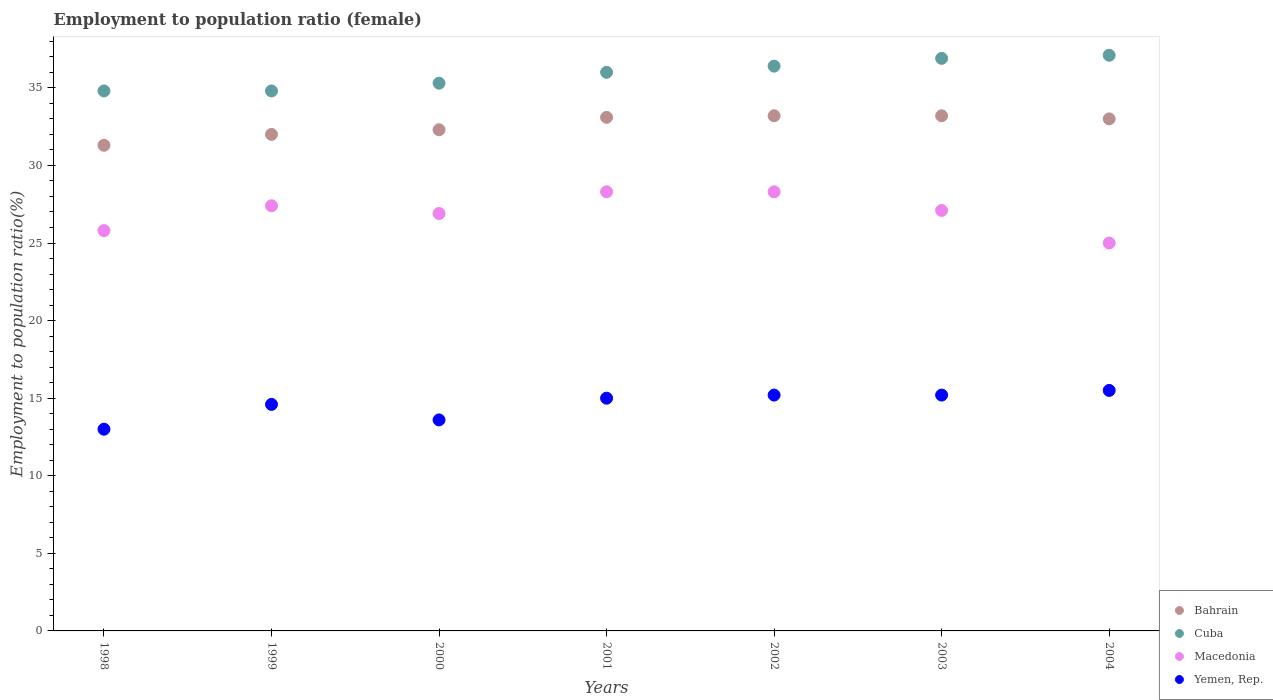What is the employment to population ratio in Yemen, Rep. in 1998?
Keep it short and to the point. 13. Across all years, what is the maximum employment to population ratio in Macedonia?
Your answer should be very brief. 28.3. Across all years, what is the minimum employment to population ratio in Yemen, Rep.?
Give a very brief answer. 13. In which year was the employment to population ratio in Macedonia minimum?
Give a very brief answer. 2004. What is the total employment to population ratio in Yemen, Rep. in the graph?
Give a very brief answer. 102.1. What is the difference between the employment to population ratio in Macedonia in 2000 and that in 2003?
Your answer should be compact. -0.2. What is the difference between the employment to population ratio in Macedonia in 2002 and the employment to population ratio in Bahrain in 1999?
Your answer should be very brief. -3.7. What is the average employment to population ratio in Macedonia per year?
Your answer should be compact. 26.97. In the year 2003, what is the difference between the employment to population ratio in Bahrain and employment to population ratio in Cuba?
Give a very brief answer. -3.7. What is the ratio of the employment to population ratio in Bahrain in 2002 to that in 2004?
Offer a terse response. 1.01. Is the employment to population ratio in Yemen, Rep. in 1999 less than that in 2001?
Give a very brief answer. Yes. Is the difference between the employment to population ratio in Bahrain in 2001 and 2002 greater than the difference between the employment to population ratio in Cuba in 2001 and 2002?
Provide a short and direct response. Yes. What is the difference between the highest and the second highest employment to population ratio in Cuba?
Make the answer very short. 0.2. What is the difference between the highest and the lowest employment to population ratio in Yemen, Rep.?
Your answer should be compact. 2.5. Is the sum of the employment to population ratio in Cuba in 2000 and 2001 greater than the maximum employment to population ratio in Bahrain across all years?
Make the answer very short. Yes. Is it the case that in every year, the sum of the employment to population ratio in Cuba and employment to population ratio in Bahrain  is greater than the sum of employment to population ratio in Macedonia and employment to population ratio in Yemen, Rep.?
Your response must be concise. No. Is it the case that in every year, the sum of the employment to population ratio in Macedonia and employment to population ratio in Bahrain  is greater than the employment to population ratio in Cuba?
Your response must be concise. Yes. Is the employment to population ratio in Cuba strictly less than the employment to population ratio in Yemen, Rep. over the years?
Your answer should be very brief. No. How many dotlines are there?
Give a very brief answer. 4. What is the difference between two consecutive major ticks on the Y-axis?
Give a very brief answer. 5. Does the graph contain grids?
Make the answer very short. No. Where does the legend appear in the graph?
Provide a short and direct response. Bottom right. How many legend labels are there?
Give a very brief answer. 4. What is the title of the graph?
Your response must be concise. Employment to population ratio (female). Does "Cayman Islands" appear as one of the legend labels in the graph?
Your answer should be very brief. No. What is the Employment to population ratio(%) in Bahrain in 1998?
Give a very brief answer. 31.3. What is the Employment to population ratio(%) of Cuba in 1998?
Make the answer very short. 34.8. What is the Employment to population ratio(%) of Macedonia in 1998?
Your answer should be very brief. 25.8. What is the Employment to population ratio(%) of Bahrain in 1999?
Make the answer very short. 32. What is the Employment to population ratio(%) in Cuba in 1999?
Your answer should be compact. 34.8. What is the Employment to population ratio(%) of Macedonia in 1999?
Keep it short and to the point. 27.4. What is the Employment to population ratio(%) in Yemen, Rep. in 1999?
Your answer should be compact. 14.6. What is the Employment to population ratio(%) of Bahrain in 2000?
Make the answer very short. 32.3. What is the Employment to population ratio(%) in Cuba in 2000?
Provide a succinct answer. 35.3. What is the Employment to population ratio(%) in Macedonia in 2000?
Your answer should be very brief. 26.9. What is the Employment to population ratio(%) in Yemen, Rep. in 2000?
Your answer should be very brief. 13.6. What is the Employment to population ratio(%) in Bahrain in 2001?
Provide a succinct answer. 33.1. What is the Employment to population ratio(%) in Cuba in 2001?
Offer a very short reply. 36. What is the Employment to population ratio(%) of Macedonia in 2001?
Give a very brief answer. 28.3. What is the Employment to population ratio(%) of Yemen, Rep. in 2001?
Your response must be concise. 15. What is the Employment to population ratio(%) in Bahrain in 2002?
Provide a succinct answer. 33.2. What is the Employment to population ratio(%) of Cuba in 2002?
Keep it short and to the point. 36.4. What is the Employment to population ratio(%) of Macedonia in 2002?
Your response must be concise. 28.3. What is the Employment to population ratio(%) in Yemen, Rep. in 2002?
Provide a succinct answer. 15.2. What is the Employment to population ratio(%) of Bahrain in 2003?
Ensure brevity in your answer.  33.2. What is the Employment to population ratio(%) of Cuba in 2003?
Make the answer very short. 36.9. What is the Employment to population ratio(%) of Macedonia in 2003?
Give a very brief answer. 27.1. What is the Employment to population ratio(%) of Yemen, Rep. in 2003?
Provide a short and direct response. 15.2. What is the Employment to population ratio(%) of Bahrain in 2004?
Keep it short and to the point. 33. What is the Employment to population ratio(%) of Cuba in 2004?
Offer a very short reply. 37.1. What is the Employment to population ratio(%) in Macedonia in 2004?
Your answer should be very brief. 25. Across all years, what is the maximum Employment to population ratio(%) of Bahrain?
Provide a short and direct response. 33.2. Across all years, what is the maximum Employment to population ratio(%) in Cuba?
Your answer should be compact. 37.1. Across all years, what is the maximum Employment to population ratio(%) in Macedonia?
Your answer should be compact. 28.3. Across all years, what is the maximum Employment to population ratio(%) in Yemen, Rep.?
Provide a succinct answer. 15.5. Across all years, what is the minimum Employment to population ratio(%) in Bahrain?
Keep it short and to the point. 31.3. Across all years, what is the minimum Employment to population ratio(%) of Cuba?
Your response must be concise. 34.8. Across all years, what is the minimum Employment to population ratio(%) of Macedonia?
Offer a terse response. 25. Across all years, what is the minimum Employment to population ratio(%) of Yemen, Rep.?
Give a very brief answer. 13. What is the total Employment to population ratio(%) in Bahrain in the graph?
Ensure brevity in your answer.  228.1. What is the total Employment to population ratio(%) in Cuba in the graph?
Make the answer very short. 251.3. What is the total Employment to population ratio(%) of Macedonia in the graph?
Your answer should be compact. 188.8. What is the total Employment to population ratio(%) of Yemen, Rep. in the graph?
Ensure brevity in your answer.  102.1. What is the difference between the Employment to population ratio(%) in Bahrain in 1998 and that in 1999?
Provide a succinct answer. -0.7. What is the difference between the Employment to population ratio(%) in Bahrain in 1998 and that in 2000?
Your answer should be compact. -1. What is the difference between the Employment to population ratio(%) of Macedonia in 1998 and that in 2000?
Your answer should be compact. -1.1. What is the difference between the Employment to population ratio(%) in Yemen, Rep. in 1998 and that in 2000?
Give a very brief answer. -0.6. What is the difference between the Employment to population ratio(%) of Bahrain in 1998 and that in 2001?
Provide a succinct answer. -1.8. What is the difference between the Employment to population ratio(%) in Macedonia in 1998 and that in 2001?
Offer a terse response. -2.5. What is the difference between the Employment to population ratio(%) in Bahrain in 1998 and that in 2002?
Your answer should be very brief. -1.9. What is the difference between the Employment to population ratio(%) in Macedonia in 1998 and that in 2002?
Keep it short and to the point. -2.5. What is the difference between the Employment to population ratio(%) of Yemen, Rep. in 1998 and that in 2002?
Keep it short and to the point. -2.2. What is the difference between the Employment to population ratio(%) of Bahrain in 1998 and that in 2003?
Provide a succinct answer. -1.9. What is the difference between the Employment to population ratio(%) of Cuba in 1998 and that in 2004?
Your answer should be very brief. -2.3. What is the difference between the Employment to population ratio(%) in Yemen, Rep. in 1998 and that in 2004?
Provide a short and direct response. -2.5. What is the difference between the Employment to population ratio(%) in Macedonia in 1999 and that in 2000?
Keep it short and to the point. 0.5. What is the difference between the Employment to population ratio(%) of Bahrain in 1999 and that in 2001?
Offer a very short reply. -1.1. What is the difference between the Employment to population ratio(%) in Macedonia in 1999 and that in 2001?
Your response must be concise. -0.9. What is the difference between the Employment to population ratio(%) in Yemen, Rep. in 1999 and that in 2001?
Provide a short and direct response. -0.4. What is the difference between the Employment to population ratio(%) of Macedonia in 1999 and that in 2002?
Keep it short and to the point. -0.9. What is the difference between the Employment to population ratio(%) in Yemen, Rep. in 1999 and that in 2002?
Your response must be concise. -0.6. What is the difference between the Employment to population ratio(%) of Bahrain in 1999 and that in 2003?
Your answer should be compact. -1.2. What is the difference between the Employment to population ratio(%) of Macedonia in 1999 and that in 2003?
Your response must be concise. 0.3. What is the difference between the Employment to population ratio(%) of Yemen, Rep. in 1999 and that in 2003?
Offer a very short reply. -0.6. What is the difference between the Employment to population ratio(%) of Cuba in 1999 and that in 2004?
Keep it short and to the point. -2.3. What is the difference between the Employment to population ratio(%) of Cuba in 2000 and that in 2001?
Offer a very short reply. -0.7. What is the difference between the Employment to population ratio(%) in Macedonia in 2000 and that in 2001?
Offer a terse response. -1.4. What is the difference between the Employment to population ratio(%) of Bahrain in 2000 and that in 2002?
Offer a very short reply. -0.9. What is the difference between the Employment to population ratio(%) in Bahrain in 2000 and that in 2003?
Your answer should be very brief. -0.9. What is the difference between the Employment to population ratio(%) in Macedonia in 2000 and that in 2003?
Provide a succinct answer. -0.2. What is the difference between the Employment to population ratio(%) in Bahrain in 2000 and that in 2004?
Your answer should be compact. -0.7. What is the difference between the Employment to population ratio(%) of Cuba in 2000 and that in 2004?
Your response must be concise. -1.8. What is the difference between the Employment to population ratio(%) of Macedonia in 2000 and that in 2004?
Provide a succinct answer. 1.9. What is the difference between the Employment to population ratio(%) in Yemen, Rep. in 2000 and that in 2004?
Keep it short and to the point. -1.9. What is the difference between the Employment to population ratio(%) in Cuba in 2001 and that in 2002?
Make the answer very short. -0.4. What is the difference between the Employment to population ratio(%) in Yemen, Rep. in 2001 and that in 2002?
Offer a terse response. -0.2. What is the difference between the Employment to population ratio(%) of Bahrain in 2001 and that in 2003?
Provide a short and direct response. -0.1. What is the difference between the Employment to population ratio(%) in Yemen, Rep. in 2001 and that in 2003?
Keep it short and to the point. -0.2. What is the difference between the Employment to population ratio(%) of Bahrain in 2001 and that in 2004?
Ensure brevity in your answer.  0.1. What is the difference between the Employment to population ratio(%) in Cuba in 2001 and that in 2004?
Your answer should be very brief. -1.1. What is the difference between the Employment to population ratio(%) of Yemen, Rep. in 2001 and that in 2004?
Keep it short and to the point. -0.5. What is the difference between the Employment to population ratio(%) in Bahrain in 2002 and that in 2003?
Your response must be concise. 0. What is the difference between the Employment to population ratio(%) in Macedonia in 2002 and that in 2004?
Your response must be concise. 3.3. What is the difference between the Employment to population ratio(%) of Bahrain in 2003 and that in 2004?
Your answer should be very brief. 0.2. What is the difference between the Employment to population ratio(%) of Macedonia in 2003 and that in 2004?
Offer a very short reply. 2.1. What is the difference between the Employment to population ratio(%) in Bahrain in 1998 and the Employment to population ratio(%) in Macedonia in 1999?
Keep it short and to the point. 3.9. What is the difference between the Employment to population ratio(%) of Bahrain in 1998 and the Employment to population ratio(%) of Yemen, Rep. in 1999?
Provide a short and direct response. 16.7. What is the difference between the Employment to population ratio(%) in Cuba in 1998 and the Employment to population ratio(%) in Macedonia in 1999?
Keep it short and to the point. 7.4. What is the difference between the Employment to population ratio(%) of Cuba in 1998 and the Employment to population ratio(%) of Yemen, Rep. in 1999?
Provide a short and direct response. 20.2. What is the difference between the Employment to population ratio(%) in Macedonia in 1998 and the Employment to population ratio(%) in Yemen, Rep. in 1999?
Ensure brevity in your answer.  11.2. What is the difference between the Employment to population ratio(%) in Bahrain in 1998 and the Employment to population ratio(%) in Cuba in 2000?
Provide a succinct answer. -4. What is the difference between the Employment to population ratio(%) in Cuba in 1998 and the Employment to population ratio(%) in Macedonia in 2000?
Give a very brief answer. 7.9. What is the difference between the Employment to population ratio(%) of Cuba in 1998 and the Employment to population ratio(%) of Yemen, Rep. in 2000?
Make the answer very short. 21.2. What is the difference between the Employment to population ratio(%) of Cuba in 1998 and the Employment to population ratio(%) of Macedonia in 2001?
Make the answer very short. 6.5. What is the difference between the Employment to population ratio(%) of Cuba in 1998 and the Employment to population ratio(%) of Yemen, Rep. in 2001?
Offer a terse response. 19.8. What is the difference between the Employment to population ratio(%) of Bahrain in 1998 and the Employment to population ratio(%) of Macedonia in 2002?
Provide a short and direct response. 3. What is the difference between the Employment to population ratio(%) of Bahrain in 1998 and the Employment to population ratio(%) of Yemen, Rep. in 2002?
Your answer should be compact. 16.1. What is the difference between the Employment to population ratio(%) of Cuba in 1998 and the Employment to population ratio(%) of Macedonia in 2002?
Provide a succinct answer. 6.5. What is the difference between the Employment to population ratio(%) of Cuba in 1998 and the Employment to population ratio(%) of Yemen, Rep. in 2002?
Offer a terse response. 19.6. What is the difference between the Employment to population ratio(%) of Macedonia in 1998 and the Employment to population ratio(%) of Yemen, Rep. in 2002?
Offer a terse response. 10.6. What is the difference between the Employment to population ratio(%) in Bahrain in 1998 and the Employment to population ratio(%) in Cuba in 2003?
Your answer should be very brief. -5.6. What is the difference between the Employment to population ratio(%) in Bahrain in 1998 and the Employment to population ratio(%) in Macedonia in 2003?
Your response must be concise. 4.2. What is the difference between the Employment to population ratio(%) of Cuba in 1998 and the Employment to population ratio(%) of Yemen, Rep. in 2003?
Offer a very short reply. 19.6. What is the difference between the Employment to population ratio(%) of Bahrain in 1998 and the Employment to population ratio(%) of Yemen, Rep. in 2004?
Keep it short and to the point. 15.8. What is the difference between the Employment to population ratio(%) of Cuba in 1998 and the Employment to population ratio(%) of Macedonia in 2004?
Keep it short and to the point. 9.8. What is the difference between the Employment to population ratio(%) of Cuba in 1998 and the Employment to population ratio(%) of Yemen, Rep. in 2004?
Give a very brief answer. 19.3. What is the difference between the Employment to population ratio(%) in Macedonia in 1998 and the Employment to population ratio(%) in Yemen, Rep. in 2004?
Your answer should be compact. 10.3. What is the difference between the Employment to population ratio(%) of Cuba in 1999 and the Employment to population ratio(%) of Macedonia in 2000?
Your response must be concise. 7.9. What is the difference between the Employment to population ratio(%) in Cuba in 1999 and the Employment to population ratio(%) in Yemen, Rep. in 2000?
Offer a very short reply. 21.2. What is the difference between the Employment to population ratio(%) of Macedonia in 1999 and the Employment to population ratio(%) of Yemen, Rep. in 2000?
Ensure brevity in your answer.  13.8. What is the difference between the Employment to population ratio(%) of Bahrain in 1999 and the Employment to population ratio(%) of Macedonia in 2001?
Your answer should be compact. 3.7. What is the difference between the Employment to population ratio(%) of Bahrain in 1999 and the Employment to population ratio(%) of Yemen, Rep. in 2001?
Your response must be concise. 17. What is the difference between the Employment to population ratio(%) of Cuba in 1999 and the Employment to population ratio(%) of Yemen, Rep. in 2001?
Your answer should be very brief. 19.8. What is the difference between the Employment to population ratio(%) of Macedonia in 1999 and the Employment to population ratio(%) of Yemen, Rep. in 2001?
Provide a succinct answer. 12.4. What is the difference between the Employment to population ratio(%) in Bahrain in 1999 and the Employment to population ratio(%) in Cuba in 2002?
Make the answer very short. -4.4. What is the difference between the Employment to population ratio(%) of Bahrain in 1999 and the Employment to population ratio(%) of Yemen, Rep. in 2002?
Ensure brevity in your answer.  16.8. What is the difference between the Employment to population ratio(%) of Cuba in 1999 and the Employment to population ratio(%) of Macedonia in 2002?
Give a very brief answer. 6.5. What is the difference between the Employment to population ratio(%) in Cuba in 1999 and the Employment to population ratio(%) in Yemen, Rep. in 2002?
Make the answer very short. 19.6. What is the difference between the Employment to population ratio(%) in Macedonia in 1999 and the Employment to population ratio(%) in Yemen, Rep. in 2002?
Provide a short and direct response. 12.2. What is the difference between the Employment to population ratio(%) of Bahrain in 1999 and the Employment to population ratio(%) of Macedonia in 2003?
Offer a very short reply. 4.9. What is the difference between the Employment to population ratio(%) in Bahrain in 1999 and the Employment to population ratio(%) in Yemen, Rep. in 2003?
Your answer should be compact. 16.8. What is the difference between the Employment to population ratio(%) of Cuba in 1999 and the Employment to population ratio(%) of Macedonia in 2003?
Your answer should be very brief. 7.7. What is the difference between the Employment to population ratio(%) in Cuba in 1999 and the Employment to population ratio(%) in Yemen, Rep. in 2003?
Give a very brief answer. 19.6. What is the difference between the Employment to population ratio(%) in Bahrain in 1999 and the Employment to population ratio(%) in Cuba in 2004?
Provide a succinct answer. -5.1. What is the difference between the Employment to population ratio(%) in Cuba in 1999 and the Employment to population ratio(%) in Macedonia in 2004?
Make the answer very short. 9.8. What is the difference between the Employment to population ratio(%) in Cuba in 1999 and the Employment to population ratio(%) in Yemen, Rep. in 2004?
Provide a short and direct response. 19.3. What is the difference between the Employment to population ratio(%) of Macedonia in 1999 and the Employment to population ratio(%) of Yemen, Rep. in 2004?
Ensure brevity in your answer.  11.9. What is the difference between the Employment to population ratio(%) of Bahrain in 2000 and the Employment to population ratio(%) of Cuba in 2001?
Ensure brevity in your answer.  -3.7. What is the difference between the Employment to population ratio(%) of Bahrain in 2000 and the Employment to population ratio(%) of Yemen, Rep. in 2001?
Ensure brevity in your answer.  17.3. What is the difference between the Employment to population ratio(%) of Cuba in 2000 and the Employment to population ratio(%) of Macedonia in 2001?
Your response must be concise. 7. What is the difference between the Employment to population ratio(%) of Cuba in 2000 and the Employment to population ratio(%) of Yemen, Rep. in 2001?
Ensure brevity in your answer.  20.3. What is the difference between the Employment to population ratio(%) in Macedonia in 2000 and the Employment to population ratio(%) in Yemen, Rep. in 2001?
Provide a short and direct response. 11.9. What is the difference between the Employment to population ratio(%) of Bahrain in 2000 and the Employment to population ratio(%) of Cuba in 2002?
Provide a short and direct response. -4.1. What is the difference between the Employment to population ratio(%) in Bahrain in 2000 and the Employment to population ratio(%) in Macedonia in 2002?
Your answer should be very brief. 4. What is the difference between the Employment to population ratio(%) of Cuba in 2000 and the Employment to population ratio(%) of Macedonia in 2002?
Your response must be concise. 7. What is the difference between the Employment to population ratio(%) in Cuba in 2000 and the Employment to population ratio(%) in Yemen, Rep. in 2002?
Offer a very short reply. 20.1. What is the difference between the Employment to population ratio(%) in Bahrain in 2000 and the Employment to population ratio(%) in Cuba in 2003?
Provide a succinct answer. -4.6. What is the difference between the Employment to population ratio(%) of Bahrain in 2000 and the Employment to population ratio(%) of Macedonia in 2003?
Give a very brief answer. 5.2. What is the difference between the Employment to population ratio(%) in Cuba in 2000 and the Employment to population ratio(%) in Macedonia in 2003?
Offer a terse response. 8.2. What is the difference between the Employment to population ratio(%) in Cuba in 2000 and the Employment to population ratio(%) in Yemen, Rep. in 2003?
Offer a very short reply. 20.1. What is the difference between the Employment to population ratio(%) in Macedonia in 2000 and the Employment to population ratio(%) in Yemen, Rep. in 2003?
Your answer should be very brief. 11.7. What is the difference between the Employment to population ratio(%) of Bahrain in 2000 and the Employment to population ratio(%) of Macedonia in 2004?
Provide a short and direct response. 7.3. What is the difference between the Employment to population ratio(%) in Cuba in 2000 and the Employment to population ratio(%) in Macedonia in 2004?
Provide a succinct answer. 10.3. What is the difference between the Employment to population ratio(%) in Cuba in 2000 and the Employment to population ratio(%) in Yemen, Rep. in 2004?
Your answer should be compact. 19.8. What is the difference between the Employment to population ratio(%) in Bahrain in 2001 and the Employment to population ratio(%) in Cuba in 2002?
Your answer should be very brief. -3.3. What is the difference between the Employment to population ratio(%) of Cuba in 2001 and the Employment to population ratio(%) of Yemen, Rep. in 2002?
Offer a terse response. 20.8. What is the difference between the Employment to population ratio(%) of Bahrain in 2001 and the Employment to population ratio(%) of Macedonia in 2003?
Your response must be concise. 6. What is the difference between the Employment to population ratio(%) of Bahrain in 2001 and the Employment to population ratio(%) of Yemen, Rep. in 2003?
Offer a terse response. 17.9. What is the difference between the Employment to population ratio(%) of Cuba in 2001 and the Employment to population ratio(%) of Macedonia in 2003?
Make the answer very short. 8.9. What is the difference between the Employment to population ratio(%) in Cuba in 2001 and the Employment to population ratio(%) in Yemen, Rep. in 2003?
Keep it short and to the point. 20.8. What is the difference between the Employment to population ratio(%) of Macedonia in 2001 and the Employment to population ratio(%) of Yemen, Rep. in 2003?
Give a very brief answer. 13.1. What is the difference between the Employment to population ratio(%) of Bahrain in 2001 and the Employment to population ratio(%) of Macedonia in 2004?
Make the answer very short. 8.1. What is the difference between the Employment to population ratio(%) in Cuba in 2001 and the Employment to population ratio(%) in Macedonia in 2004?
Ensure brevity in your answer.  11. What is the difference between the Employment to population ratio(%) in Macedonia in 2001 and the Employment to population ratio(%) in Yemen, Rep. in 2004?
Ensure brevity in your answer.  12.8. What is the difference between the Employment to population ratio(%) in Bahrain in 2002 and the Employment to population ratio(%) in Macedonia in 2003?
Give a very brief answer. 6.1. What is the difference between the Employment to population ratio(%) of Cuba in 2002 and the Employment to population ratio(%) of Macedonia in 2003?
Your response must be concise. 9.3. What is the difference between the Employment to population ratio(%) in Cuba in 2002 and the Employment to population ratio(%) in Yemen, Rep. in 2003?
Your response must be concise. 21.2. What is the difference between the Employment to population ratio(%) of Cuba in 2002 and the Employment to population ratio(%) of Yemen, Rep. in 2004?
Give a very brief answer. 20.9. What is the difference between the Employment to population ratio(%) of Macedonia in 2002 and the Employment to population ratio(%) of Yemen, Rep. in 2004?
Provide a short and direct response. 12.8. What is the difference between the Employment to population ratio(%) of Bahrain in 2003 and the Employment to population ratio(%) of Macedonia in 2004?
Ensure brevity in your answer.  8.2. What is the difference between the Employment to population ratio(%) in Cuba in 2003 and the Employment to population ratio(%) in Macedonia in 2004?
Give a very brief answer. 11.9. What is the difference between the Employment to population ratio(%) of Cuba in 2003 and the Employment to population ratio(%) of Yemen, Rep. in 2004?
Keep it short and to the point. 21.4. What is the difference between the Employment to population ratio(%) in Macedonia in 2003 and the Employment to population ratio(%) in Yemen, Rep. in 2004?
Offer a very short reply. 11.6. What is the average Employment to population ratio(%) in Bahrain per year?
Make the answer very short. 32.59. What is the average Employment to population ratio(%) of Cuba per year?
Provide a succinct answer. 35.9. What is the average Employment to population ratio(%) of Macedonia per year?
Your answer should be compact. 26.97. What is the average Employment to population ratio(%) in Yemen, Rep. per year?
Your answer should be compact. 14.59. In the year 1998, what is the difference between the Employment to population ratio(%) in Bahrain and Employment to population ratio(%) in Macedonia?
Ensure brevity in your answer.  5.5. In the year 1998, what is the difference between the Employment to population ratio(%) of Cuba and Employment to population ratio(%) of Yemen, Rep.?
Make the answer very short. 21.8. In the year 1998, what is the difference between the Employment to population ratio(%) of Macedonia and Employment to population ratio(%) of Yemen, Rep.?
Provide a short and direct response. 12.8. In the year 1999, what is the difference between the Employment to population ratio(%) in Bahrain and Employment to population ratio(%) in Macedonia?
Your answer should be very brief. 4.6. In the year 1999, what is the difference between the Employment to population ratio(%) of Cuba and Employment to population ratio(%) of Macedonia?
Offer a very short reply. 7.4. In the year 1999, what is the difference between the Employment to population ratio(%) in Cuba and Employment to population ratio(%) in Yemen, Rep.?
Offer a terse response. 20.2. In the year 2000, what is the difference between the Employment to population ratio(%) in Bahrain and Employment to population ratio(%) in Cuba?
Ensure brevity in your answer.  -3. In the year 2000, what is the difference between the Employment to population ratio(%) in Cuba and Employment to population ratio(%) in Yemen, Rep.?
Offer a very short reply. 21.7. In the year 2001, what is the difference between the Employment to population ratio(%) of Bahrain and Employment to population ratio(%) of Cuba?
Provide a short and direct response. -2.9. In the year 2001, what is the difference between the Employment to population ratio(%) of Cuba and Employment to population ratio(%) of Macedonia?
Your response must be concise. 7.7. In the year 2001, what is the difference between the Employment to population ratio(%) in Cuba and Employment to population ratio(%) in Yemen, Rep.?
Provide a short and direct response. 21. In the year 2001, what is the difference between the Employment to population ratio(%) in Macedonia and Employment to population ratio(%) in Yemen, Rep.?
Give a very brief answer. 13.3. In the year 2002, what is the difference between the Employment to population ratio(%) of Bahrain and Employment to population ratio(%) of Cuba?
Offer a very short reply. -3.2. In the year 2002, what is the difference between the Employment to population ratio(%) of Cuba and Employment to population ratio(%) of Macedonia?
Ensure brevity in your answer.  8.1. In the year 2002, what is the difference between the Employment to population ratio(%) in Cuba and Employment to population ratio(%) in Yemen, Rep.?
Your answer should be very brief. 21.2. In the year 2003, what is the difference between the Employment to population ratio(%) in Bahrain and Employment to population ratio(%) in Macedonia?
Your answer should be very brief. 6.1. In the year 2003, what is the difference between the Employment to population ratio(%) in Cuba and Employment to population ratio(%) in Macedonia?
Ensure brevity in your answer.  9.8. In the year 2003, what is the difference between the Employment to population ratio(%) of Cuba and Employment to population ratio(%) of Yemen, Rep.?
Offer a very short reply. 21.7. In the year 2004, what is the difference between the Employment to population ratio(%) of Bahrain and Employment to population ratio(%) of Macedonia?
Your answer should be compact. 8. In the year 2004, what is the difference between the Employment to population ratio(%) of Bahrain and Employment to population ratio(%) of Yemen, Rep.?
Give a very brief answer. 17.5. In the year 2004, what is the difference between the Employment to population ratio(%) in Cuba and Employment to population ratio(%) in Yemen, Rep.?
Your response must be concise. 21.6. In the year 2004, what is the difference between the Employment to population ratio(%) in Macedonia and Employment to population ratio(%) in Yemen, Rep.?
Offer a very short reply. 9.5. What is the ratio of the Employment to population ratio(%) in Bahrain in 1998 to that in 1999?
Make the answer very short. 0.98. What is the ratio of the Employment to population ratio(%) in Macedonia in 1998 to that in 1999?
Your answer should be very brief. 0.94. What is the ratio of the Employment to population ratio(%) of Yemen, Rep. in 1998 to that in 1999?
Your response must be concise. 0.89. What is the ratio of the Employment to population ratio(%) of Cuba in 1998 to that in 2000?
Ensure brevity in your answer.  0.99. What is the ratio of the Employment to population ratio(%) in Macedonia in 1998 to that in 2000?
Keep it short and to the point. 0.96. What is the ratio of the Employment to population ratio(%) of Yemen, Rep. in 1998 to that in 2000?
Offer a very short reply. 0.96. What is the ratio of the Employment to population ratio(%) of Bahrain in 1998 to that in 2001?
Keep it short and to the point. 0.95. What is the ratio of the Employment to population ratio(%) of Cuba in 1998 to that in 2001?
Give a very brief answer. 0.97. What is the ratio of the Employment to population ratio(%) in Macedonia in 1998 to that in 2001?
Offer a very short reply. 0.91. What is the ratio of the Employment to population ratio(%) of Yemen, Rep. in 1998 to that in 2001?
Offer a very short reply. 0.87. What is the ratio of the Employment to population ratio(%) in Bahrain in 1998 to that in 2002?
Your answer should be compact. 0.94. What is the ratio of the Employment to population ratio(%) of Cuba in 1998 to that in 2002?
Your answer should be very brief. 0.96. What is the ratio of the Employment to population ratio(%) of Macedonia in 1998 to that in 2002?
Make the answer very short. 0.91. What is the ratio of the Employment to population ratio(%) in Yemen, Rep. in 1998 to that in 2002?
Provide a succinct answer. 0.86. What is the ratio of the Employment to population ratio(%) of Bahrain in 1998 to that in 2003?
Keep it short and to the point. 0.94. What is the ratio of the Employment to population ratio(%) in Cuba in 1998 to that in 2003?
Provide a short and direct response. 0.94. What is the ratio of the Employment to population ratio(%) in Yemen, Rep. in 1998 to that in 2003?
Offer a terse response. 0.86. What is the ratio of the Employment to population ratio(%) in Bahrain in 1998 to that in 2004?
Your answer should be compact. 0.95. What is the ratio of the Employment to population ratio(%) of Cuba in 1998 to that in 2004?
Provide a short and direct response. 0.94. What is the ratio of the Employment to population ratio(%) in Macedonia in 1998 to that in 2004?
Make the answer very short. 1.03. What is the ratio of the Employment to population ratio(%) of Yemen, Rep. in 1998 to that in 2004?
Offer a terse response. 0.84. What is the ratio of the Employment to population ratio(%) in Cuba in 1999 to that in 2000?
Make the answer very short. 0.99. What is the ratio of the Employment to population ratio(%) of Macedonia in 1999 to that in 2000?
Your answer should be very brief. 1.02. What is the ratio of the Employment to population ratio(%) of Yemen, Rep. in 1999 to that in 2000?
Your response must be concise. 1.07. What is the ratio of the Employment to population ratio(%) in Bahrain in 1999 to that in 2001?
Keep it short and to the point. 0.97. What is the ratio of the Employment to population ratio(%) of Cuba in 1999 to that in 2001?
Give a very brief answer. 0.97. What is the ratio of the Employment to population ratio(%) of Macedonia in 1999 to that in 2001?
Provide a succinct answer. 0.97. What is the ratio of the Employment to population ratio(%) of Yemen, Rep. in 1999 to that in 2001?
Your response must be concise. 0.97. What is the ratio of the Employment to population ratio(%) of Bahrain in 1999 to that in 2002?
Give a very brief answer. 0.96. What is the ratio of the Employment to population ratio(%) of Cuba in 1999 to that in 2002?
Ensure brevity in your answer.  0.96. What is the ratio of the Employment to population ratio(%) of Macedonia in 1999 to that in 2002?
Ensure brevity in your answer.  0.97. What is the ratio of the Employment to population ratio(%) of Yemen, Rep. in 1999 to that in 2002?
Make the answer very short. 0.96. What is the ratio of the Employment to population ratio(%) of Bahrain in 1999 to that in 2003?
Your answer should be compact. 0.96. What is the ratio of the Employment to population ratio(%) of Cuba in 1999 to that in 2003?
Your answer should be compact. 0.94. What is the ratio of the Employment to population ratio(%) in Macedonia in 1999 to that in 2003?
Your answer should be very brief. 1.01. What is the ratio of the Employment to population ratio(%) of Yemen, Rep. in 1999 to that in 2003?
Offer a very short reply. 0.96. What is the ratio of the Employment to population ratio(%) in Bahrain in 1999 to that in 2004?
Ensure brevity in your answer.  0.97. What is the ratio of the Employment to population ratio(%) of Cuba in 1999 to that in 2004?
Offer a terse response. 0.94. What is the ratio of the Employment to population ratio(%) in Macedonia in 1999 to that in 2004?
Keep it short and to the point. 1.1. What is the ratio of the Employment to population ratio(%) of Yemen, Rep. in 1999 to that in 2004?
Offer a very short reply. 0.94. What is the ratio of the Employment to population ratio(%) in Bahrain in 2000 to that in 2001?
Offer a very short reply. 0.98. What is the ratio of the Employment to population ratio(%) of Cuba in 2000 to that in 2001?
Your answer should be very brief. 0.98. What is the ratio of the Employment to population ratio(%) in Macedonia in 2000 to that in 2001?
Offer a very short reply. 0.95. What is the ratio of the Employment to population ratio(%) in Yemen, Rep. in 2000 to that in 2001?
Provide a succinct answer. 0.91. What is the ratio of the Employment to population ratio(%) of Bahrain in 2000 to that in 2002?
Provide a short and direct response. 0.97. What is the ratio of the Employment to population ratio(%) of Cuba in 2000 to that in 2002?
Make the answer very short. 0.97. What is the ratio of the Employment to population ratio(%) of Macedonia in 2000 to that in 2002?
Your response must be concise. 0.95. What is the ratio of the Employment to population ratio(%) of Yemen, Rep. in 2000 to that in 2002?
Make the answer very short. 0.89. What is the ratio of the Employment to population ratio(%) of Bahrain in 2000 to that in 2003?
Offer a terse response. 0.97. What is the ratio of the Employment to population ratio(%) in Cuba in 2000 to that in 2003?
Keep it short and to the point. 0.96. What is the ratio of the Employment to population ratio(%) in Yemen, Rep. in 2000 to that in 2003?
Your response must be concise. 0.89. What is the ratio of the Employment to population ratio(%) of Bahrain in 2000 to that in 2004?
Offer a very short reply. 0.98. What is the ratio of the Employment to population ratio(%) in Cuba in 2000 to that in 2004?
Offer a very short reply. 0.95. What is the ratio of the Employment to population ratio(%) in Macedonia in 2000 to that in 2004?
Make the answer very short. 1.08. What is the ratio of the Employment to population ratio(%) of Yemen, Rep. in 2000 to that in 2004?
Make the answer very short. 0.88. What is the ratio of the Employment to population ratio(%) of Bahrain in 2001 to that in 2002?
Make the answer very short. 1. What is the ratio of the Employment to population ratio(%) in Macedonia in 2001 to that in 2002?
Your response must be concise. 1. What is the ratio of the Employment to population ratio(%) in Bahrain in 2001 to that in 2003?
Your response must be concise. 1. What is the ratio of the Employment to population ratio(%) in Cuba in 2001 to that in 2003?
Offer a terse response. 0.98. What is the ratio of the Employment to population ratio(%) in Macedonia in 2001 to that in 2003?
Your response must be concise. 1.04. What is the ratio of the Employment to population ratio(%) of Yemen, Rep. in 2001 to that in 2003?
Your answer should be compact. 0.99. What is the ratio of the Employment to population ratio(%) of Cuba in 2001 to that in 2004?
Give a very brief answer. 0.97. What is the ratio of the Employment to population ratio(%) in Macedonia in 2001 to that in 2004?
Keep it short and to the point. 1.13. What is the ratio of the Employment to population ratio(%) in Yemen, Rep. in 2001 to that in 2004?
Provide a short and direct response. 0.97. What is the ratio of the Employment to population ratio(%) of Cuba in 2002 to that in 2003?
Ensure brevity in your answer.  0.99. What is the ratio of the Employment to population ratio(%) of Macedonia in 2002 to that in 2003?
Your response must be concise. 1.04. What is the ratio of the Employment to population ratio(%) of Yemen, Rep. in 2002 to that in 2003?
Your response must be concise. 1. What is the ratio of the Employment to population ratio(%) of Bahrain in 2002 to that in 2004?
Your response must be concise. 1.01. What is the ratio of the Employment to population ratio(%) of Cuba in 2002 to that in 2004?
Your answer should be very brief. 0.98. What is the ratio of the Employment to population ratio(%) in Macedonia in 2002 to that in 2004?
Provide a short and direct response. 1.13. What is the ratio of the Employment to population ratio(%) in Yemen, Rep. in 2002 to that in 2004?
Give a very brief answer. 0.98. What is the ratio of the Employment to population ratio(%) of Cuba in 2003 to that in 2004?
Offer a very short reply. 0.99. What is the ratio of the Employment to population ratio(%) of Macedonia in 2003 to that in 2004?
Make the answer very short. 1.08. What is the ratio of the Employment to population ratio(%) in Yemen, Rep. in 2003 to that in 2004?
Make the answer very short. 0.98. What is the difference between the highest and the second highest Employment to population ratio(%) of Bahrain?
Provide a short and direct response. 0. What is the difference between the highest and the second highest Employment to population ratio(%) in Macedonia?
Offer a very short reply. 0. What is the difference between the highest and the lowest Employment to population ratio(%) in Macedonia?
Ensure brevity in your answer.  3.3. 